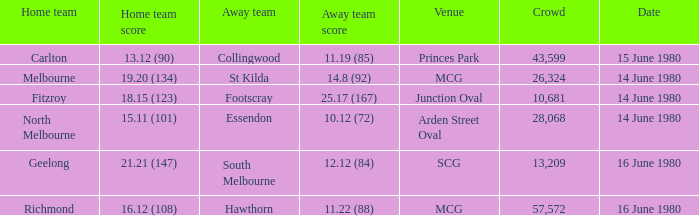On what date the footscray's away game? 14 June 1980. 